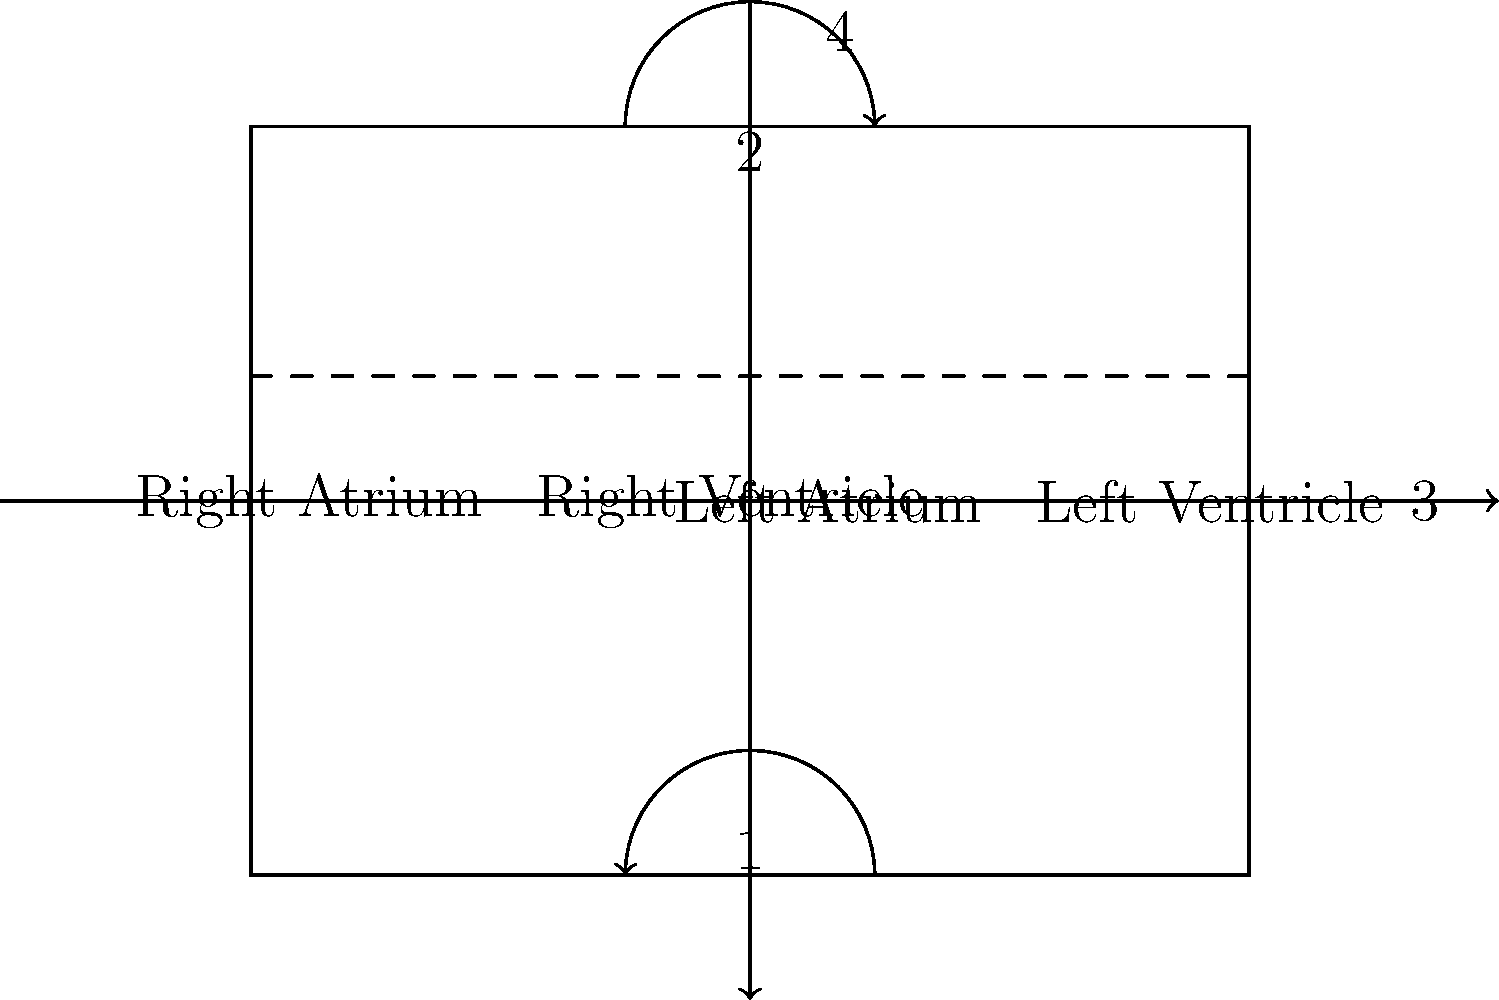As a senior nurse with extensive experience in cardiovascular care, analyze the labeled diagram of the heart chambers. Which numbered arrow correctly represents the flow of oxygenated blood from the lungs entering the heart? To answer this question, let's follow the path of blood through the heart:

1. Deoxygenated blood enters the right atrium from the body.
2. Blood flows from the right atrium to the right ventricle (arrow 1).
3. The right ventricle pumps blood to the lungs for oxygenation.
4. Oxygenated blood returns from the lungs to the left atrium.
5. Blood flows from the left atrium to the left ventricle (arrow 2).
6. The left ventricle pumps oxygenated blood to the body (arrow 3).

Arrow 4 represents the overall flow of blood through the heart, but it's not specific to oxygenated blood entering from the lungs.

The question asks about oxygenated blood from the lungs entering the heart. This occurs when blood returns from the lungs to the left atrium. The arrow that correctly represents this flow is arrow 2, which shows blood entering the left side of the heart from the top (where the pulmonary veins would connect).
Answer: 2 